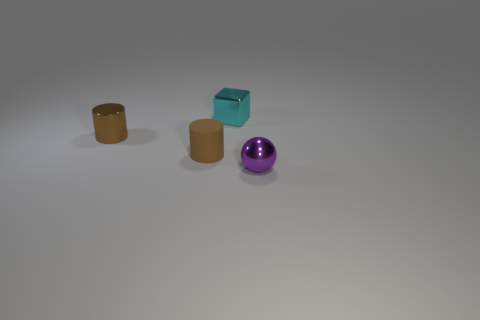There is a small thing that is the same color as the rubber cylinder; what is its shape?
Your answer should be very brief. Cylinder. The cylinder that is made of the same material as the cube is what size?
Give a very brief answer. Small. Is the size of the cyan shiny cube the same as the metal thing to the left of the cube?
Offer a terse response. Yes. What color is the small shiny thing that is both to the right of the rubber cylinder and behind the tiny purple ball?
Your answer should be compact. Cyan. How many things are either small metallic objects on the right side of the small cyan block or metallic things that are to the right of the metallic cube?
Your answer should be compact. 1. There is a shiny thing in front of the small thing on the left side of the brown object that is to the right of the tiny brown shiny object; what is its color?
Your answer should be compact. Purple. Are there any purple metal things of the same shape as the tiny cyan thing?
Keep it short and to the point. No. How many shiny cylinders are there?
Offer a terse response. 1. What is the shape of the small matte thing?
Ensure brevity in your answer.  Cylinder. What number of other purple metallic spheres are the same size as the purple metal sphere?
Offer a very short reply. 0. 